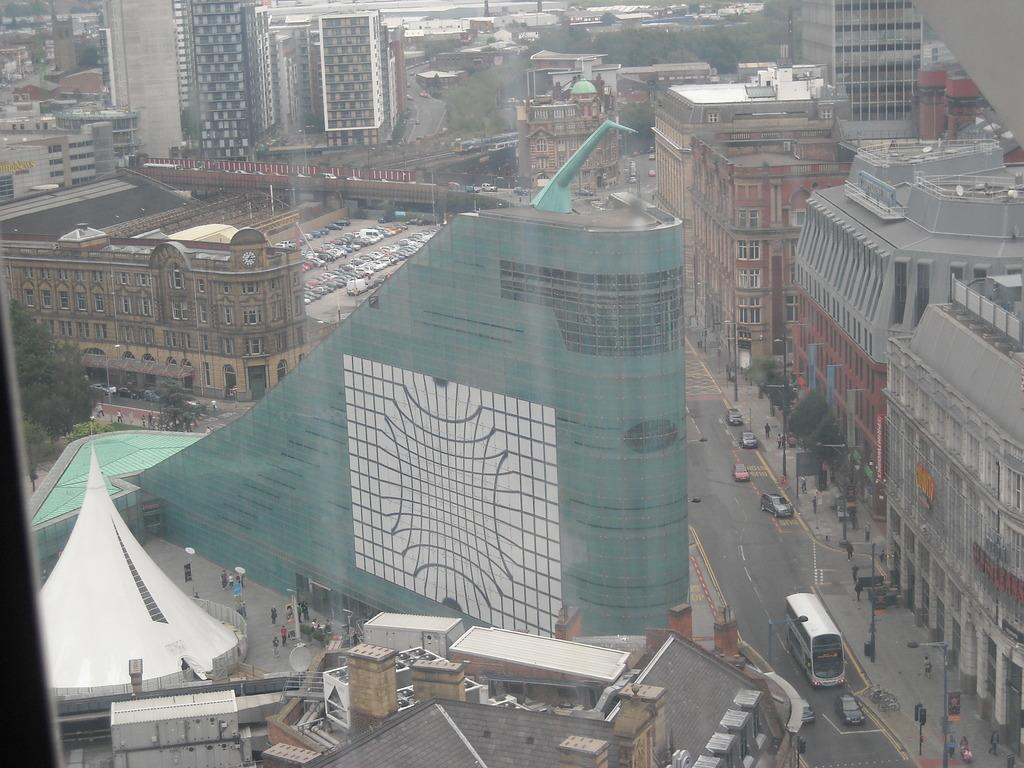Who or what can be seen in the image? There are people in the image. What else is visible on the road in the image? There are vehicles on the road in the image. What type of structures are present in the image? There are buildings in the image. What objects can be seen supporting wires or signs in the image? There are poles in the image. What type of vegetation is visible in the image? There are trees in the image. What type of tooth is being used to cut the lumber in the image? There is no tooth or lumber present in the image; it features people, vehicles, buildings, poles, and trees. What holiday is being celebrated in the image? There is no indication of a holiday being celebrated in the image. 